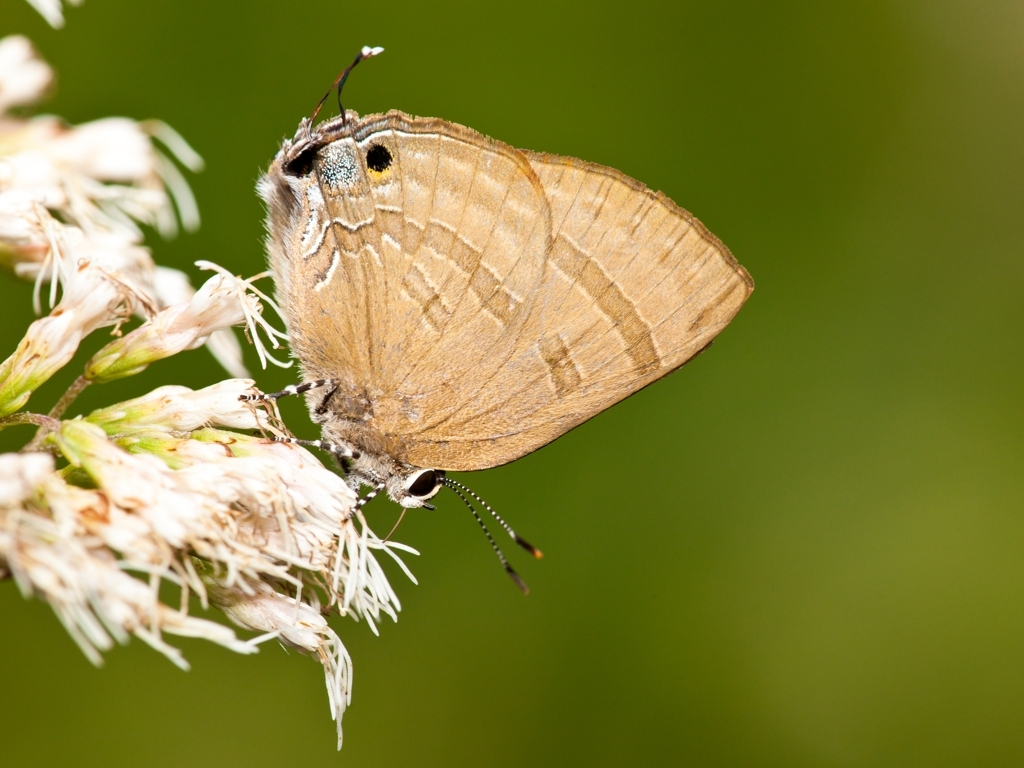What can this image tell us about the butterfly's habitat? The butterfly is perched on what looks like a cluster of white flowers in a green, natural environment. This suggests that its habitat is a region with access to flowering plants which provide nectar, indicating a meadow or a similar ecosystem that supports a diverse floral array for sustenance. 